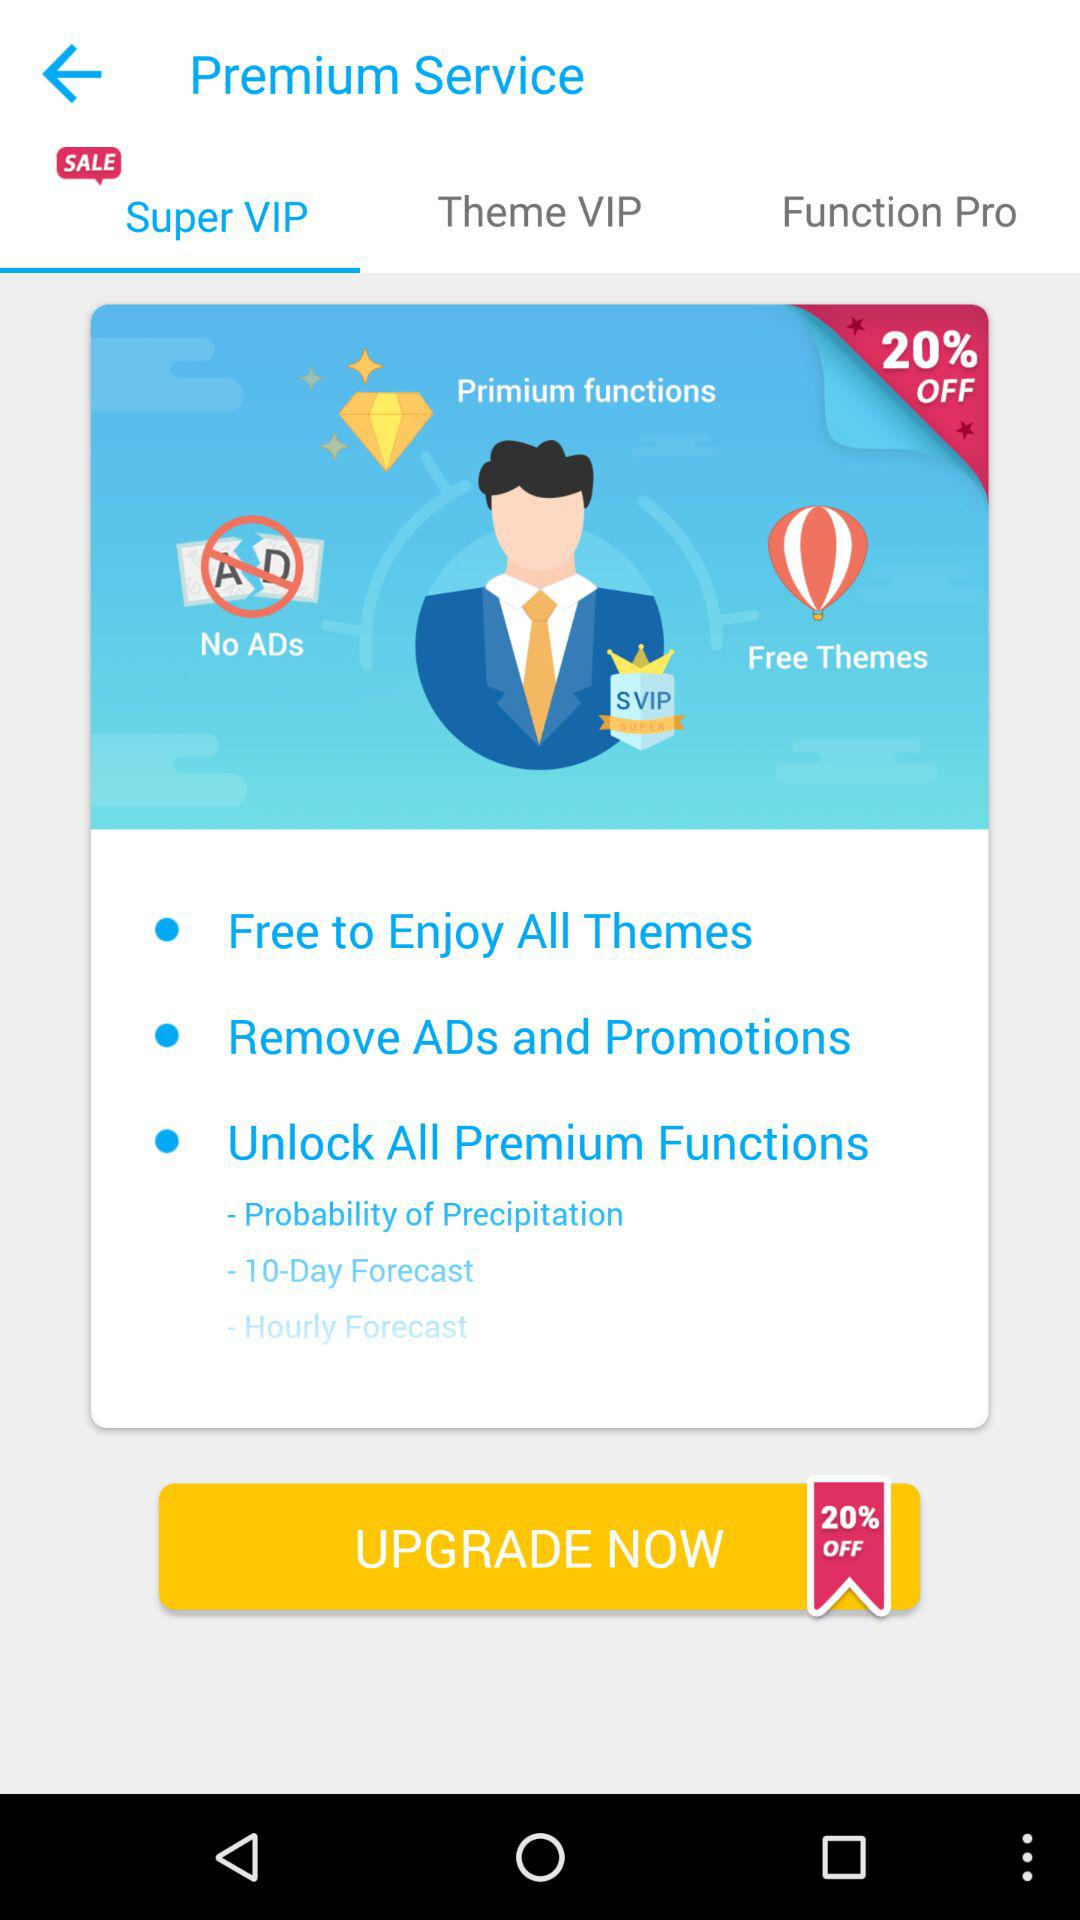Which tab is selected? The selected tab is "Super VIP". 